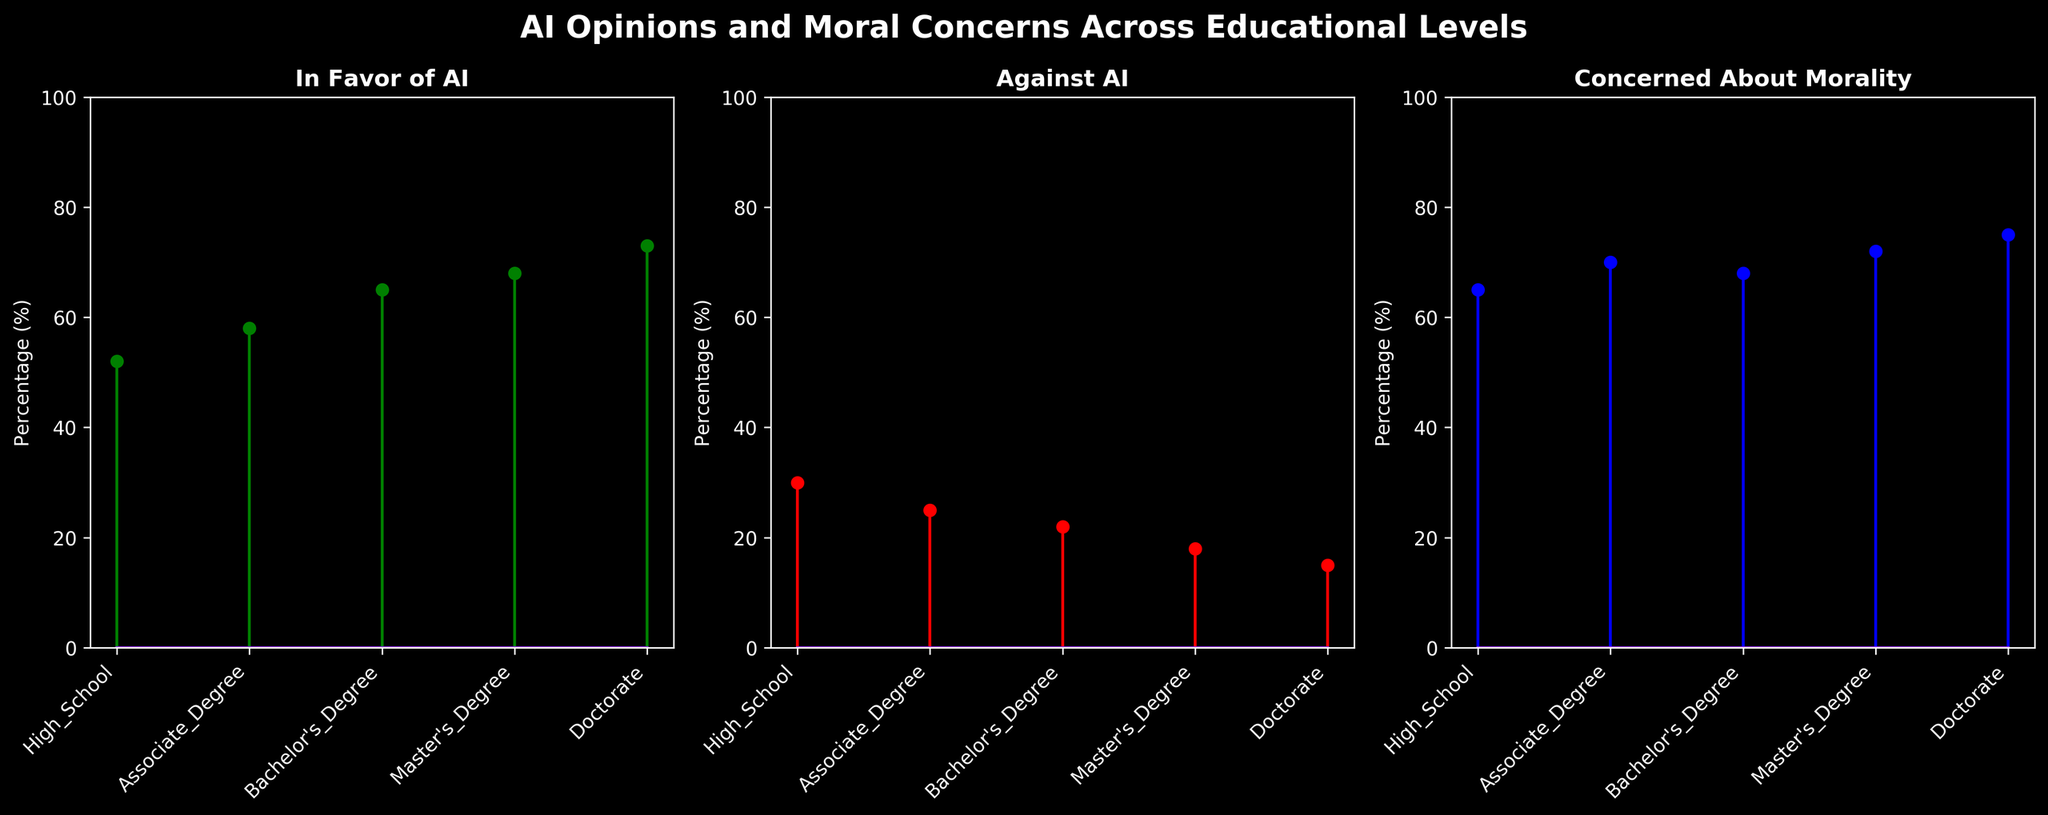What is the title of the figure? The title is present at the top of the figure and reads "AI Opinions and Moral Concerns Across Educational Levels."
Answer: AI Opinions and Moral Concerns Across Educational Levels Which educational level has the highest percentage of people in favor of AI? By looking at the green stems in the "In Favor of AI" subplot, the Doctorate level has the highest percentage of 73%.
Answer: Doctorate How many educational levels are represented in the figure? The x-axis of all subplots lists the educational levels; counting them gives us five levels.
Answer: Five What is the percentage difference in favor of AI between those with a High School education and those with a Doctorate? The percentage in favor of AI for High School is 52% and for Doctorate is 73%. The difference is 73% - 52% = 21%.
Answer: 21% Which group has the highest concern about the morality of AI? In the "Concerned About Morality" subplot, indicated by the blue stems, the Doctorate level has the highest percentage at 75%.
Answer: Doctorate Is there a difference between the percentage of people against AI at the Master’s Degree and Bachelor's Degree levels? In the "Against AI" subplot, the percentage for Master’s Degree is 18% and for Bachelor's Degree is 22%. The difference is 22% - 18% = 4%.
Answer: 4% Which subplot shows the highest overall percentages across all educational levels? Observing all three subplots, the "Concerned About Morality" subplot has the consistently highest percentages across educational levels.
Answer: Concerned About Morality Do those with higher educational levels (Bachelor's, Master’s, and Doctorate) show more concern about the morality of AI than those with lower educational levels (High School and Associate Degree)? Higher educational levels (68%, 72%, and 75%) demonstrate more concern than lower educational levels (65% and 70%).
Answer: Yes What is the sum of the percentages in favor of AI across all educational levels? Adding the percentages in the "In Favor of AI" subplot: 52% + 58% + 65% + 68% + 73% = 316%.
Answer: 316% At which educational level does the smallest percentage of people oppose AI? In the "Against AI" subplot, the Doctorate level has the smallest percentage at 15%.
Answer: Doctorate 